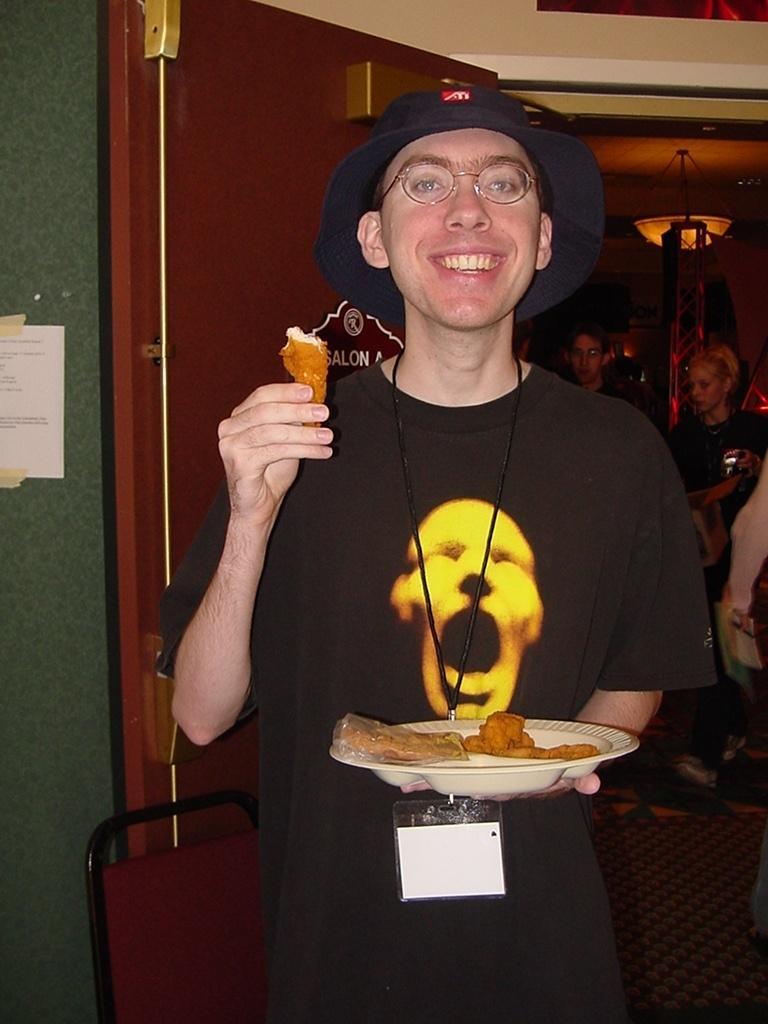Could you give a brief overview of what you see in this image? In the middle of the image a person is standing, holding a plate and smiling. Behind him we can see a chair, wall, door and few people are standing. 